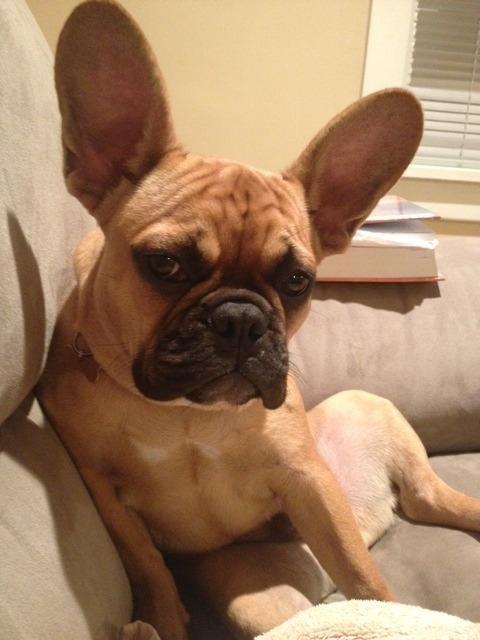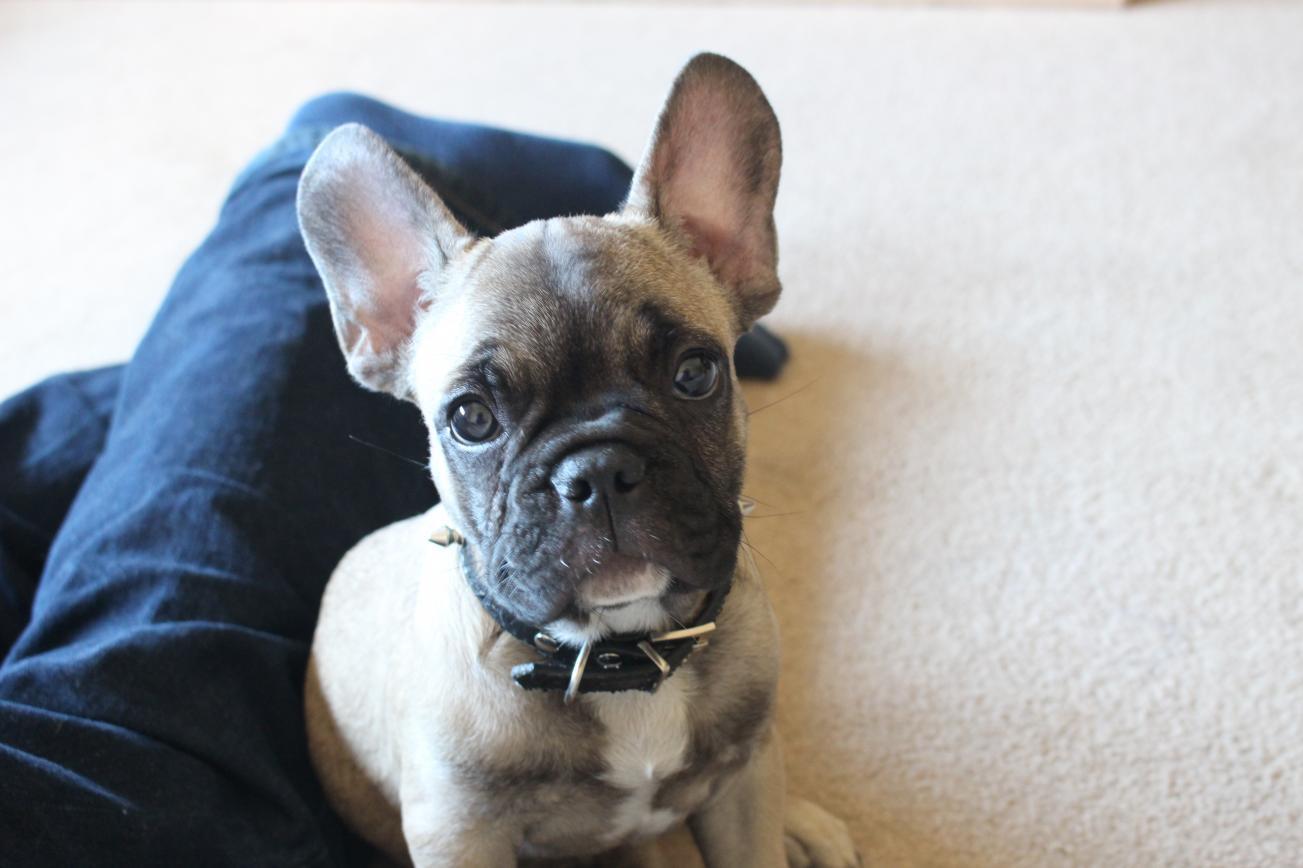The first image is the image on the left, the second image is the image on the right. Analyze the images presented: Is the assertion "At least one image shows a dark-furred dog with masking tape around at least one ear." valid? Answer yes or no. No. The first image is the image on the left, the second image is the image on the right. Considering the images on both sides, is "The dog in the left image has tape on its ears." valid? Answer yes or no. No. 